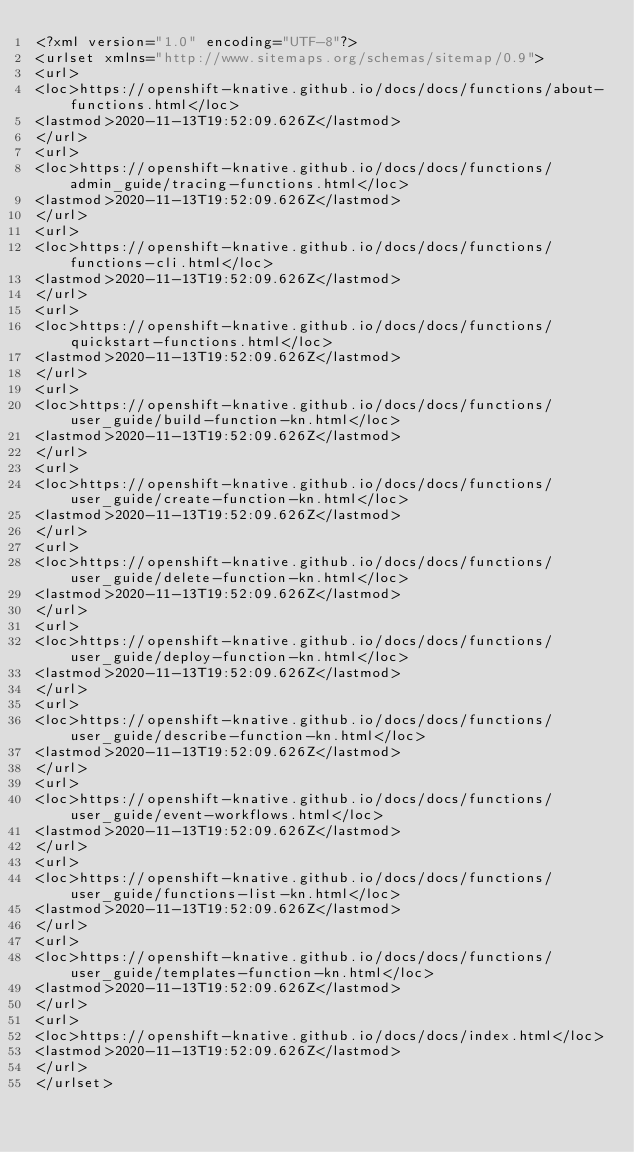<code> <loc_0><loc_0><loc_500><loc_500><_XML_><?xml version="1.0" encoding="UTF-8"?>
<urlset xmlns="http://www.sitemaps.org/schemas/sitemap/0.9">
<url>
<loc>https://openshift-knative.github.io/docs/docs/functions/about-functions.html</loc>
<lastmod>2020-11-13T19:52:09.626Z</lastmod>
</url>
<url>
<loc>https://openshift-knative.github.io/docs/docs/functions/admin_guide/tracing-functions.html</loc>
<lastmod>2020-11-13T19:52:09.626Z</lastmod>
</url>
<url>
<loc>https://openshift-knative.github.io/docs/docs/functions/functions-cli.html</loc>
<lastmod>2020-11-13T19:52:09.626Z</lastmod>
</url>
<url>
<loc>https://openshift-knative.github.io/docs/docs/functions/quickstart-functions.html</loc>
<lastmod>2020-11-13T19:52:09.626Z</lastmod>
</url>
<url>
<loc>https://openshift-knative.github.io/docs/docs/functions/user_guide/build-function-kn.html</loc>
<lastmod>2020-11-13T19:52:09.626Z</lastmod>
</url>
<url>
<loc>https://openshift-knative.github.io/docs/docs/functions/user_guide/create-function-kn.html</loc>
<lastmod>2020-11-13T19:52:09.626Z</lastmod>
</url>
<url>
<loc>https://openshift-knative.github.io/docs/docs/functions/user_guide/delete-function-kn.html</loc>
<lastmod>2020-11-13T19:52:09.626Z</lastmod>
</url>
<url>
<loc>https://openshift-knative.github.io/docs/docs/functions/user_guide/deploy-function-kn.html</loc>
<lastmod>2020-11-13T19:52:09.626Z</lastmod>
</url>
<url>
<loc>https://openshift-knative.github.io/docs/docs/functions/user_guide/describe-function-kn.html</loc>
<lastmod>2020-11-13T19:52:09.626Z</lastmod>
</url>
<url>
<loc>https://openshift-knative.github.io/docs/docs/functions/user_guide/event-workflows.html</loc>
<lastmod>2020-11-13T19:52:09.626Z</lastmod>
</url>
<url>
<loc>https://openshift-knative.github.io/docs/docs/functions/user_guide/functions-list-kn.html</loc>
<lastmod>2020-11-13T19:52:09.626Z</lastmod>
</url>
<url>
<loc>https://openshift-knative.github.io/docs/docs/functions/user_guide/templates-function-kn.html</loc>
<lastmod>2020-11-13T19:52:09.626Z</lastmod>
</url>
<url>
<loc>https://openshift-knative.github.io/docs/docs/index.html</loc>
<lastmod>2020-11-13T19:52:09.626Z</lastmod>
</url>
</urlset></code> 